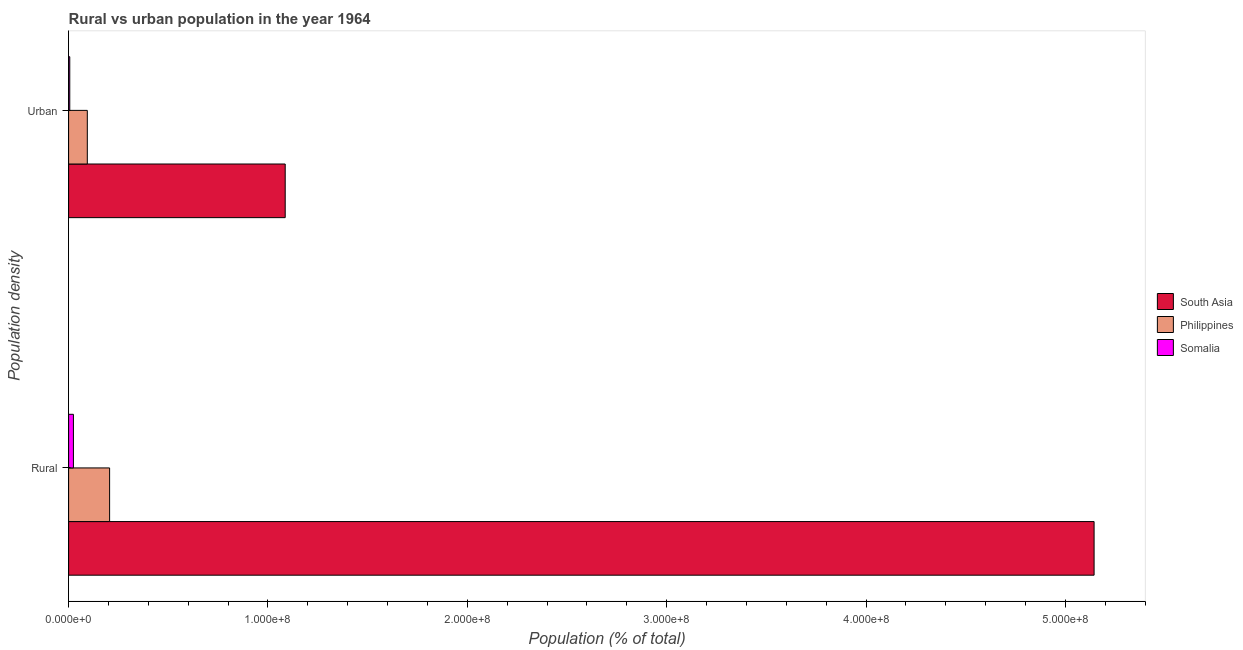How many different coloured bars are there?
Keep it short and to the point. 3. Are the number of bars per tick equal to the number of legend labels?
Offer a terse response. Yes. How many bars are there on the 2nd tick from the top?
Ensure brevity in your answer.  3. What is the label of the 2nd group of bars from the top?
Offer a terse response. Rural. What is the rural population density in Philippines?
Provide a succinct answer. 2.06e+07. Across all countries, what is the maximum urban population density?
Make the answer very short. 1.09e+08. Across all countries, what is the minimum rural population density?
Your answer should be very brief. 2.42e+06. In which country was the rural population density minimum?
Make the answer very short. Somalia. What is the total urban population density in the graph?
Ensure brevity in your answer.  1.19e+08. What is the difference between the urban population density in South Asia and that in Philippines?
Offer a very short reply. 9.93e+07. What is the difference between the urban population density in Philippines and the rural population density in Somalia?
Offer a very short reply. 6.97e+06. What is the average rural population density per country?
Keep it short and to the point. 1.79e+08. What is the difference between the urban population density and rural population density in Somalia?
Provide a short and direct response. -1.83e+06. In how many countries, is the urban population density greater than 260000000 %?
Give a very brief answer. 0. What is the ratio of the urban population density in Somalia to that in South Asia?
Offer a very short reply. 0.01. In how many countries, is the rural population density greater than the average rural population density taken over all countries?
Offer a terse response. 1. What does the 3rd bar from the top in Urban represents?
Keep it short and to the point. South Asia. Are all the bars in the graph horizontal?
Make the answer very short. Yes. Does the graph contain any zero values?
Your response must be concise. No. Does the graph contain grids?
Make the answer very short. No. How many legend labels are there?
Offer a terse response. 3. What is the title of the graph?
Give a very brief answer. Rural vs urban population in the year 1964. What is the label or title of the X-axis?
Offer a very short reply. Population (% of total). What is the label or title of the Y-axis?
Offer a terse response. Population density. What is the Population (% of total) in South Asia in Rural?
Offer a very short reply. 5.14e+08. What is the Population (% of total) of Philippines in Rural?
Provide a short and direct response. 2.06e+07. What is the Population (% of total) of Somalia in Rural?
Your answer should be compact. 2.42e+06. What is the Population (% of total) of South Asia in Urban?
Offer a very short reply. 1.09e+08. What is the Population (% of total) of Philippines in Urban?
Make the answer very short. 9.39e+06. What is the Population (% of total) of Somalia in Urban?
Provide a short and direct response. 5.84e+05. Across all Population density, what is the maximum Population (% of total) in South Asia?
Ensure brevity in your answer.  5.14e+08. Across all Population density, what is the maximum Population (% of total) in Philippines?
Your response must be concise. 2.06e+07. Across all Population density, what is the maximum Population (% of total) of Somalia?
Your answer should be very brief. 2.42e+06. Across all Population density, what is the minimum Population (% of total) in South Asia?
Make the answer very short. 1.09e+08. Across all Population density, what is the minimum Population (% of total) in Philippines?
Keep it short and to the point. 9.39e+06. Across all Population density, what is the minimum Population (% of total) in Somalia?
Give a very brief answer. 5.84e+05. What is the total Population (% of total) in South Asia in the graph?
Give a very brief answer. 6.23e+08. What is the total Population (% of total) in Philippines in the graph?
Make the answer very short. 3.00e+07. What is the total Population (% of total) of Somalia in the graph?
Provide a short and direct response. 3.00e+06. What is the difference between the Population (% of total) in South Asia in Rural and that in Urban?
Your response must be concise. 4.06e+08. What is the difference between the Population (% of total) of Philippines in Rural and that in Urban?
Offer a terse response. 1.12e+07. What is the difference between the Population (% of total) of Somalia in Rural and that in Urban?
Provide a succinct answer. 1.83e+06. What is the difference between the Population (% of total) of South Asia in Rural and the Population (% of total) of Philippines in Urban?
Your response must be concise. 5.05e+08. What is the difference between the Population (% of total) of South Asia in Rural and the Population (% of total) of Somalia in Urban?
Make the answer very short. 5.14e+08. What is the difference between the Population (% of total) of Philippines in Rural and the Population (% of total) of Somalia in Urban?
Give a very brief answer. 2.00e+07. What is the average Population (% of total) in South Asia per Population density?
Your answer should be compact. 3.12e+08. What is the average Population (% of total) of Philippines per Population density?
Offer a very short reply. 1.50e+07. What is the average Population (% of total) of Somalia per Population density?
Ensure brevity in your answer.  1.50e+06. What is the difference between the Population (% of total) in South Asia and Population (% of total) in Philippines in Rural?
Provide a succinct answer. 4.94e+08. What is the difference between the Population (% of total) of South Asia and Population (% of total) of Somalia in Rural?
Make the answer very short. 5.12e+08. What is the difference between the Population (% of total) of Philippines and Population (% of total) of Somalia in Rural?
Your answer should be very brief. 1.82e+07. What is the difference between the Population (% of total) of South Asia and Population (% of total) of Philippines in Urban?
Your answer should be compact. 9.93e+07. What is the difference between the Population (% of total) of South Asia and Population (% of total) of Somalia in Urban?
Keep it short and to the point. 1.08e+08. What is the difference between the Population (% of total) of Philippines and Population (% of total) of Somalia in Urban?
Give a very brief answer. 8.81e+06. What is the ratio of the Population (% of total) of South Asia in Rural to that in Urban?
Ensure brevity in your answer.  4.73. What is the ratio of the Population (% of total) of Philippines in Rural to that in Urban?
Provide a succinct answer. 2.19. What is the ratio of the Population (% of total) of Somalia in Rural to that in Urban?
Offer a terse response. 4.14. What is the difference between the highest and the second highest Population (% of total) of South Asia?
Provide a short and direct response. 4.06e+08. What is the difference between the highest and the second highest Population (% of total) of Philippines?
Offer a very short reply. 1.12e+07. What is the difference between the highest and the second highest Population (% of total) in Somalia?
Your answer should be very brief. 1.83e+06. What is the difference between the highest and the lowest Population (% of total) of South Asia?
Make the answer very short. 4.06e+08. What is the difference between the highest and the lowest Population (% of total) of Philippines?
Provide a short and direct response. 1.12e+07. What is the difference between the highest and the lowest Population (% of total) in Somalia?
Give a very brief answer. 1.83e+06. 